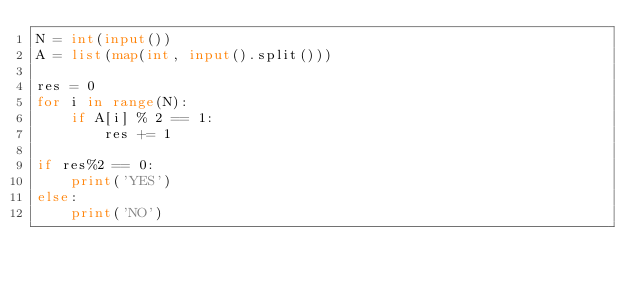<code> <loc_0><loc_0><loc_500><loc_500><_Python_>N = int(input())
A = list(map(int, input().split()))

res = 0
for i in range(N):
    if A[i] % 2 == 1:
        res += 1
        
if res%2 == 0:
    print('YES')
else:
    print('NO')</code> 